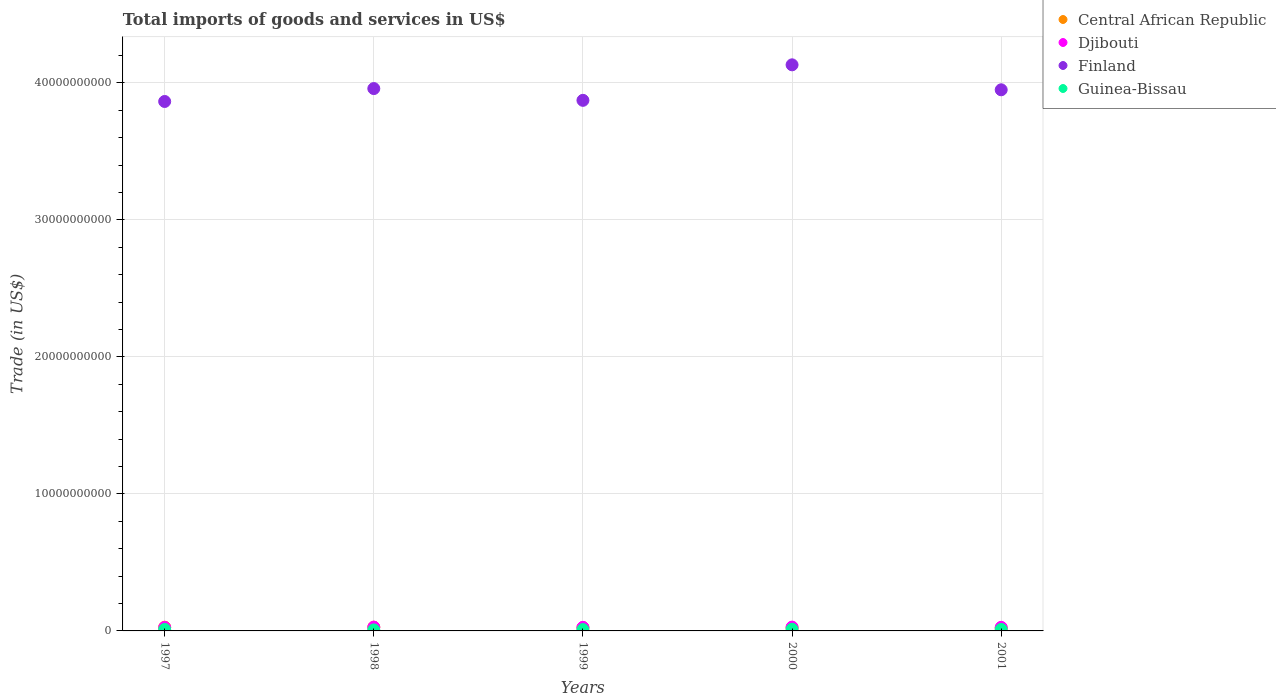What is the total imports of goods and services in Finland in 2001?
Provide a short and direct response. 3.95e+1. Across all years, what is the maximum total imports of goods and services in Central African Republic?
Keep it short and to the point. 2.75e+08. Across all years, what is the minimum total imports of goods and services in Guinea-Bissau?
Make the answer very short. 7.40e+07. What is the total total imports of goods and services in Guinea-Bissau in the graph?
Ensure brevity in your answer.  5.05e+08. What is the difference between the total imports of goods and services in Central African Republic in 1999 and that in 2000?
Ensure brevity in your answer.  8.51e+06. What is the difference between the total imports of goods and services in Central African Republic in 2000 and the total imports of goods and services in Finland in 2001?
Your answer should be very brief. -3.93e+1. What is the average total imports of goods and services in Central African Republic per year?
Offer a very short reply. 2.45e+08. In the year 2000, what is the difference between the total imports of goods and services in Central African Republic and total imports of goods and services in Djibouti?
Keep it short and to the point. -4.65e+07. In how many years, is the total imports of goods and services in Djibouti greater than 22000000000 US$?
Your response must be concise. 0. What is the ratio of the total imports of goods and services in Guinea-Bissau in 1999 to that in 2001?
Your answer should be compact. 0.91. Is the total imports of goods and services in Djibouti in 1998 less than that in 1999?
Your answer should be compact. No. What is the difference between the highest and the second highest total imports of goods and services in Central African Republic?
Provide a short and direct response. 3.32e+06. What is the difference between the highest and the lowest total imports of goods and services in Guinea-Bissau?
Give a very brief answer. 4.86e+07. In how many years, is the total imports of goods and services in Finland greater than the average total imports of goods and services in Finland taken over all years?
Provide a succinct answer. 2. Is the sum of the total imports of goods and services in Finland in 1997 and 2001 greater than the maximum total imports of goods and services in Guinea-Bissau across all years?
Keep it short and to the point. Yes. Is it the case that in every year, the sum of the total imports of goods and services in Djibouti and total imports of goods and services in Finland  is greater than the total imports of goods and services in Guinea-Bissau?
Provide a succinct answer. Yes. Does the total imports of goods and services in Djibouti monotonically increase over the years?
Offer a very short reply. No. Is the total imports of goods and services in Central African Republic strictly less than the total imports of goods and services in Djibouti over the years?
Make the answer very short. No. How many years are there in the graph?
Your answer should be very brief. 5. What is the difference between two consecutive major ticks on the Y-axis?
Provide a succinct answer. 1.00e+1. Does the graph contain any zero values?
Make the answer very short. No. Where does the legend appear in the graph?
Ensure brevity in your answer.  Top right. How many legend labels are there?
Provide a succinct answer. 4. How are the legend labels stacked?
Your answer should be compact. Vertical. What is the title of the graph?
Your response must be concise. Total imports of goods and services in US$. What is the label or title of the X-axis?
Your response must be concise. Years. What is the label or title of the Y-axis?
Provide a succinct answer. Trade (in US$). What is the Trade (in US$) in Central African Republic in 1997?
Provide a short and direct response. 2.71e+08. What is the Trade (in US$) of Djibouti in 1997?
Your answer should be very brief. 2.53e+08. What is the Trade (in US$) of Finland in 1997?
Ensure brevity in your answer.  3.86e+1. What is the Trade (in US$) in Guinea-Bissau in 1997?
Make the answer very short. 1.07e+08. What is the Trade (in US$) in Central African Republic in 1998?
Provide a short and direct response. 2.75e+08. What is the Trade (in US$) in Djibouti in 1998?
Keep it short and to the point. 2.75e+08. What is the Trade (in US$) of Finland in 1998?
Your answer should be very brief. 3.96e+1. What is the Trade (in US$) of Guinea-Bissau in 1998?
Ensure brevity in your answer.  7.40e+07. What is the Trade (in US$) of Central African Republic in 1999?
Provide a succinct answer. 2.40e+08. What is the Trade (in US$) in Djibouti in 1999?
Your response must be concise. 2.59e+08. What is the Trade (in US$) of Finland in 1999?
Provide a short and direct response. 3.87e+1. What is the Trade (in US$) in Guinea-Bissau in 1999?
Give a very brief answer. 9.61e+07. What is the Trade (in US$) in Central African Republic in 2000?
Offer a terse response. 2.31e+08. What is the Trade (in US$) in Djibouti in 2000?
Provide a succinct answer. 2.78e+08. What is the Trade (in US$) of Finland in 2000?
Your answer should be compact. 4.13e+1. What is the Trade (in US$) in Guinea-Bissau in 2000?
Provide a short and direct response. 1.23e+08. What is the Trade (in US$) of Central African Republic in 2001?
Your answer should be very brief. 2.10e+08. What is the Trade (in US$) of Djibouti in 2001?
Ensure brevity in your answer.  2.62e+08. What is the Trade (in US$) of Finland in 2001?
Your response must be concise. 3.95e+1. What is the Trade (in US$) in Guinea-Bissau in 2001?
Provide a short and direct response. 1.05e+08. Across all years, what is the maximum Trade (in US$) of Central African Republic?
Provide a short and direct response. 2.75e+08. Across all years, what is the maximum Trade (in US$) of Djibouti?
Keep it short and to the point. 2.78e+08. Across all years, what is the maximum Trade (in US$) of Finland?
Give a very brief answer. 4.13e+1. Across all years, what is the maximum Trade (in US$) in Guinea-Bissau?
Your response must be concise. 1.23e+08. Across all years, what is the minimum Trade (in US$) in Central African Republic?
Ensure brevity in your answer.  2.10e+08. Across all years, what is the minimum Trade (in US$) in Djibouti?
Your response must be concise. 2.53e+08. Across all years, what is the minimum Trade (in US$) in Finland?
Keep it short and to the point. 3.86e+1. Across all years, what is the minimum Trade (in US$) in Guinea-Bissau?
Make the answer very short. 7.40e+07. What is the total Trade (in US$) of Central African Republic in the graph?
Offer a terse response. 1.23e+09. What is the total Trade (in US$) in Djibouti in the graph?
Your response must be concise. 1.33e+09. What is the total Trade (in US$) in Finland in the graph?
Make the answer very short. 1.98e+11. What is the total Trade (in US$) of Guinea-Bissau in the graph?
Make the answer very short. 5.05e+08. What is the difference between the Trade (in US$) in Central African Republic in 1997 and that in 1998?
Give a very brief answer. -3.32e+06. What is the difference between the Trade (in US$) of Djibouti in 1997 and that in 1998?
Ensure brevity in your answer.  -2.19e+07. What is the difference between the Trade (in US$) in Finland in 1997 and that in 1998?
Your response must be concise. -9.42e+08. What is the difference between the Trade (in US$) of Guinea-Bissau in 1997 and that in 1998?
Your response must be concise. 3.31e+07. What is the difference between the Trade (in US$) of Central African Republic in 1997 and that in 1999?
Give a very brief answer. 3.16e+07. What is the difference between the Trade (in US$) in Djibouti in 1997 and that in 1999?
Your answer should be very brief. -6.22e+06. What is the difference between the Trade (in US$) of Finland in 1997 and that in 1999?
Keep it short and to the point. -8.34e+07. What is the difference between the Trade (in US$) in Guinea-Bissau in 1997 and that in 1999?
Keep it short and to the point. 1.10e+07. What is the difference between the Trade (in US$) in Central African Republic in 1997 and that in 2000?
Ensure brevity in your answer.  4.01e+07. What is the difference between the Trade (in US$) in Djibouti in 1997 and that in 2000?
Provide a short and direct response. -2.47e+07. What is the difference between the Trade (in US$) in Finland in 1997 and that in 2000?
Provide a succinct answer. -2.67e+09. What is the difference between the Trade (in US$) of Guinea-Bissau in 1997 and that in 2000?
Make the answer very short. -1.55e+07. What is the difference between the Trade (in US$) in Central African Republic in 1997 and that in 2001?
Offer a very short reply. 6.10e+07. What is the difference between the Trade (in US$) of Djibouti in 1997 and that in 2001?
Offer a very short reply. -9.00e+06. What is the difference between the Trade (in US$) in Finland in 1997 and that in 2001?
Offer a terse response. -8.53e+08. What is the difference between the Trade (in US$) in Guinea-Bissau in 1997 and that in 2001?
Make the answer very short. 1.89e+06. What is the difference between the Trade (in US$) in Central African Republic in 1998 and that in 1999?
Offer a very short reply. 3.49e+07. What is the difference between the Trade (in US$) in Djibouti in 1998 and that in 1999?
Provide a short and direct response. 1.57e+07. What is the difference between the Trade (in US$) in Finland in 1998 and that in 1999?
Ensure brevity in your answer.  8.59e+08. What is the difference between the Trade (in US$) of Guinea-Bissau in 1998 and that in 1999?
Offer a very short reply. -2.21e+07. What is the difference between the Trade (in US$) in Central African Republic in 1998 and that in 2000?
Offer a terse response. 4.34e+07. What is the difference between the Trade (in US$) of Djibouti in 1998 and that in 2000?
Your response must be concise. -2.83e+06. What is the difference between the Trade (in US$) of Finland in 1998 and that in 2000?
Give a very brief answer. -1.73e+09. What is the difference between the Trade (in US$) of Guinea-Bissau in 1998 and that in 2000?
Provide a short and direct response. -4.86e+07. What is the difference between the Trade (in US$) of Central African Republic in 1998 and that in 2001?
Provide a short and direct response. 6.43e+07. What is the difference between the Trade (in US$) in Djibouti in 1998 and that in 2001?
Provide a succinct answer. 1.29e+07. What is the difference between the Trade (in US$) of Finland in 1998 and that in 2001?
Provide a succinct answer. 8.95e+07. What is the difference between the Trade (in US$) in Guinea-Bissau in 1998 and that in 2001?
Provide a succinct answer. -3.12e+07. What is the difference between the Trade (in US$) of Central African Republic in 1999 and that in 2000?
Offer a very short reply. 8.51e+06. What is the difference between the Trade (in US$) of Djibouti in 1999 and that in 2000?
Give a very brief answer. -1.85e+07. What is the difference between the Trade (in US$) in Finland in 1999 and that in 2000?
Offer a very short reply. -2.59e+09. What is the difference between the Trade (in US$) in Guinea-Bissau in 1999 and that in 2000?
Provide a succinct answer. -2.65e+07. What is the difference between the Trade (in US$) of Central African Republic in 1999 and that in 2001?
Give a very brief answer. 2.94e+07. What is the difference between the Trade (in US$) of Djibouti in 1999 and that in 2001?
Ensure brevity in your answer.  -2.78e+06. What is the difference between the Trade (in US$) of Finland in 1999 and that in 2001?
Give a very brief answer. -7.69e+08. What is the difference between the Trade (in US$) in Guinea-Bissau in 1999 and that in 2001?
Your response must be concise. -9.12e+06. What is the difference between the Trade (in US$) in Central African Republic in 2000 and that in 2001?
Offer a terse response. 2.09e+07. What is the difference between the Trade (in US$) in Djibouti in 2000 and that in 2001?
Ensure brevity in your answer.  1.57e+07. What is the difference between the Trade (in US$) of Finland in 2000 and that in 2001?
Keep it short and to the point. 1.82e+09. What is the difference between the Trade (in US$) of Guinea-Bissau in 2000 and that in 2001?
Provide a short and direct response. 1.74e+07. What is the difference between the Trade (in US$) in Central African Republic in 1997 and the Trade (in US$) in Djibouti in 1998?
Your response must be concise. -3.56e+06. What is the difference between the Trade (in US$) in Central African Republic in 1997 and the Trade (in US$) in Finland in 1998?
Offer a very short reply. -3.93e+1. What is the difference between the Trade (in US$) of Central African Republic in 1997 and the Trade (in US$) of Guinea-Bissau in 1998?
Your answer should be compact. 1.97e+08. What is the difference between the Trade (in US$) of Djibouti in 1997 and the Trade (in US$) of Finland in 1998?
Provide a short and direct response. -3.93e+1. What is the difference between the Trade (in US$) in Djibouti in 1997 and the Trade (in US$) in Guinea-Bissau in 1998?
Offer a terse response. 1.79e+08. What is the difference between the Trade (in US$) in Finland in 1997 and the Trade (in US$) in Guinea-Bissau in 1998?
Your answer should be compact. 3.86e+1. What is the difference between the Trade (in US$) of Central African Republic in 1997 and the Trade (in US$) of Djibouti in 1999?
Offer a terse response. 1.21e+07. What is the difference between the Trade (in US$) of Central African Republic in 1997 and the Trade (in US$) of Finland in 1999?
Provide a succinct answer. -3.84e+1. What is the difference between the Trade (in US$) of Central African Republic in 1997 and the Trade (in US$) of Guinea-Bissau in 1999?
Provide a short and direct response. 1.75e+08. What is the difference between the Trade (in US$) of Djibouti in 1997 and the Trade (in US$) of Finland in 1999?
Provide a short and direct response. -3.85e+1. What is the difference between the Trade (in US$) of Djibouti in 1997 and the Trade (in US$) of Guinea-Bissau in 1999?
Your answer should be compact. 1.57e+08. What is the difference between the Trade (in US$) of Finland in 1997 and the Trade (in US$) of Guinea-Bissau in 1999?
Provide a succinct answer. 3.85e+1. What is the difference between the Trade (in US$) in Central African Republic in 1997 and the Trade (in US$) in Djibouti in 2000?
Provide a succinct answer. -6.39e+06. What is the difference between the Trade (in US$) of Central African Republic in 1997 and the Trade (in US$) of Finland in 2000?
Your answer should be compact. -4.10e+1. What is the difference between the Trade (in US$) in Central African Republic in 1997 and the Trade (in US$) in Guinea-Bissau in 2000?
Ensure brevity in your answer.  1.49e+08. What is the difference between the Trade (in US$) of Djibouti in 1997 and the Trade (in US$) of Finland in 2000?
Provide a succinct answer. -4.11e+1. What is the difference between the Trade (in US$) of Djibouti in 1997 and the Trade (in US$) of Guinea-Bissau in 2000?
Your answer should be very brief. 1.30e+08. What is the difference between the Trade (in US$) of Finland in 1997 and the Trade (in US$) of Guinea-Bissau in 2000?
Provide a short and direct response. 3.85e+1. What is the difference between the Trade (in US$) in Central African Republic in 1997 and the Trade (in US$) in Djibouti in 2001?
Offer a terse response. 9.32e+06. What is the difference between the Trade (in US$) in Central African Republic in 1997 and the Trade (in US$) in Finland in 2001?
Your response must be concise. -3.92e+1. What is the difference between the Trade (in US$) in Central African Republic in 1997 and the Trade (in US$) in Guinea-Bissau in 2001?
Provide a succinct answer. 1.66e+08. What is the difference between the Trade (in US$) of Djibouti in 1997 and the Trade (in US$) of Finland in 2001?
Provide a short and direct response. -3.92e+1. What is the difference between the Trade (in US$) in Djibouti in 1997 and the Trade (in US$) in Guinea-Bissau in 2001?
Your response must be concise. 1.48e+08. What is the difference between the Trade (in US$) in Finland in 1997 and the Trade (in US$) in Guinea-Bissau in 2001?
Provide a short and direct response. 3.85e+1. What is the difference between the Trade (in US$) of Central African Republic in 1998 and the Trade (in US$) of Djibouti in 1999?
Give a very brief answer. 1.54e+07. What is the difference between the Trade (in US$) of Central African Republic in 1998 and the Trade (in US$) of Finland in 1999?
Keep it short and to the point. -3.84e+1. What is the difference between the Trade (in US$) of Central African Republic in 1998 and the Trade (in US$) of Guinea-Bissau in 1999?
Your response must be concise. 1.79e+08. What is the difference between the Trade (in US$) in Djibouti in 1998 and the Trade (in US$) in Finland in 1999?
Keep it short and to the point. -3.84e+1. What is the difference between the Trade (in US$) of Djibouti in 1998 and the Trade (in US$) of Guinea-Bissau in 1999?
Keep it short and to the point. 1.79e+08. What is the difference between the Trade (in US$) of Finland in 1998 and the Trade (in US$) of Guinea-Bissau in 1999?
Provide a succinct answer. 3.95e+1. What is the difference between the Trade (in US$) in Central African Republic in 1998 and the Trade (in US$) in Djibouti in 2000?
Keep it short and to the point. -3.07e+06. What is the difference between the Trade (in US$) of Central African Republic in 1998 and the Trade (in US$) of Finland in 2000?
Provide a succinct answer. -4.10e+1. What is the difference between the Trade (in US$) of Central African Republic in 1998 and the Trade (in US$) of Guinea-Bissau in 2000?
Offer a very short reply. 1.52e+08. What is the difference between the Trade (in US$) of Djibouti in 1998 and the Trade (in US$) of Finland in 2000?
Your response must be concise. -4.10e+1. What is the difference between the Trade (in US$) in Djibouti in 1998 and the Trade (in US$) in Guinea-Bissau in 2000?
Provide a succinct answer. 1.52e+08. What is the difference between the Trade (in US$) in Finland in 1998 and the Trade (in US$) in Guinea-Bissau in 2000?
Your answer should be compact. 3.95e+1. What is the difference between the Trade (in US$) in Central African Republic in 1998 and the Trade (in US$) in Djibouti in 2001?
Your answer should be very brief. 1.26e+07. What is the difference between the Trade (in US$) in Central African Republic in 1998 and the Trade (in US$) in Finland in 2001?
Give a very brief answer. -3.92e+1. What is the difference between the Trade (in US$) of Central African Republic in 1998 and the Trade (in US$) of Guinea-Bissau in 2001?
Provide a succinct answer. 1.69e+08. What is the difference between the Trade (in US$) in Djibouti in 1998 and the Trade (in US$) in Finland in 2001?
Offer a terse response. -3.92e+1. What is the difference between the Trade (in US$) of Djibouti in 1998 and the Trade (in US$) of Guinea-Bissau in 2001?
Make the answer very short. 1.70e+08. What is the difference between the Trade (in US$) of Finland in 1998 and the Trade (in US$) of Guinea-Bissau in 2001?
Ensure brevity in your answer.  3.95e+1. What is the difference between the Trade (in US$) in Central African Republic in 1999 and the Trade (in US$) in Djibouti in 2000?
Offer a very short reply. -3.80e+07. What is the difference between the Trade (in US$) in Central African Republic in 1999 and the Trade (in US$) in Finland in 2000?
Keep it short and to the point. -4.11e+1. What is the difference between the Trade (in US$) of Central African Republic in 1999 and the Trade (in US$) of Guinea-Bissau in 2000?
Keep it short and to the point. 1.17e+08. What is the difference between the Trade (in US$) in Djibouti in 1999 and the Trade (in US$) in Finland in 2000?
Provide a short and direct response. -4.11e+1. What is the difference between the Trade (in US$) of Djibouti in 1999 and the Trade (in US$) of Guinea-Bissau in 2000?
Provide a succinct answer. 1.37e+08. What is the difference between the Trade (in US$) in Finland in 1999 and the Trade (in US$) in Guinea-Bissau in 2000?
Provide a succinct answer. 3.86e+1. What is the difference between the Trade (in US$) of Central African Republic in 1999 and the Trade (in US$) of Djibouti in 2001?
Ensure brevity in your answer.  -2.22e+07. What is the difference between the Trade (in US$) in Central African Republic in 1999 and the Trade (in US$) in Finland in 2001?
Your answer should be very brief. -3.93e+1. What is the difference between the Trade (in US$) of Central African Republic in 1999 and the Trade (in US$) of Guinea-Bissau in 2001?
Give a very brief answer. 1.35e+08. What is the difference between the Trade (in US$) in Djibouti in 1999 and the Trade (in US$) in Finland in 2001?
Make the answer very short. -3.92e+1. What is the difference between the Trade (in US$) in Djibouti in 1999 and the Trade (in US$) in Guinea-Bissau in 2001?
Offer a very short reply. 1.54e+08. What is the difference between the Trade (in US$) of Finland in 1999 and the Trade (in US$) of Guinea-Bissau in 2001?
Your answer should be very brief. 3.86e+1. What is the difference between the Trade (in US$) of Central African Republic in 2000 and the Trade (in US$) of Djibouti in 2001?
Your answer should be very brief. -3.08e+07. What is the difference between the Trade (in US$) in Central African Republic in 2000 and the Trade (in US$) in Finland in 2001?
Offer a terse response. -3.93e+1. What is the difference between the Trade (in US$) of Central African Republic in 2000 and the Trade (in US$) of Guinea-Bissau in 2001?
Offer a very short reply. 1.26e+08. What is the difference between the Trade (in US$) of Djibouti in 2000 and the Trade (in US$) of Finland in 2001?
Offer a terse response. -3.92e+1. What is the difference between the Trade (in US$) in Djibouti in 2000 and the Trade (in US$) in Guinea-Bissau in 2001?
Your answer should be compact. 1.73e+08. What is the difference between the Trade (in US$) of Finland in 2000 and the Trade (in US$) of Guinea-Bissau in 2001?
Keep it short and to the point. 4.12e+1. What is the average Trade (in US$) in Central African Republic per year?
Provide a succinct answer. 2.45e+08. What is the average Trade (in US$) in Djibouti per year?
Your answer should be compact. 2.65e+08. What is the average Trade (in US$) of Finland per year?
Keep it short and to the point. 3.95e+1. What is the average Trade (in US$) of Guinea-Bissau per year?
Keep it short and to the point. 1.01e+08. In the year 1997, what is the difference between the Trade (in US$) of Central African Republic and Trade (in US$) of Djibouti?
Give a very brief answer. 1.83e+07. In the year 1997, what is the difference between the Trade (in US$) in Central African Republic and Trade (in US$) in Finland?
Provide a succinct answer. -3.84e+1. In the year 1997, what is the difference between the Trade (in US$) in Central African Republic and Trade (in US$) in Guinea-Bissau?
Your answer should be very brief. 1.64e+08. In the year 1997, what is the difference between the Trade (in US$) of Djibouti and Trade (in US$) of Finland?
Make the answer very short. -3.84e+1. In the year 1997, what is the difference between the Trade (in US$) of Djibouti and Trade (in US$) of Guinea-Bissau?
Provide a succinct answer. 1.46e+08. In the year 1997, what is the difference between the Trade (in US$) in Finland and Trade (in US$) in Guinea-Bissau?
Your answer should be very brief. 3.85e+1. In the year 1998, what is the difference between the Trade (in US$) of Central African Republic and Trade (in US$) of Djibouti?
Offer a terse response. -2.39e+05. In the year 1998, what is the difference between the Trade (in US$) in Central African Republic and Trade (in US$) in Finland?
Offer a terse response. -3.93e+1. In the year 1998, what is the difference between the Trade (in US$) in Central African Republic and Trade (in US$) in Guinea-Bissau?
Your response must be concise. 2.01e+08. In the year 1998, what is the difference between the Trade (in US$) in Djibouti and Trade (in US$) in Finland?
Make the answer very short. -3.93e+1. In the year 1998, what is the difference between the Trade (in US$) of Djibouti and Trade (in US$) of Guinea-Bissau?
Offer a terse response. 2.01e+08. In the year 1998, what is the difference between the Trade (in US$) in Finland and Trade (in US$) in Guinea-Bissau?
Ensure brevity in your answer.  3.95e+1. In the year 1999, what is the difference between the Trade (in US$) in Central African Republic and Trade (in US$) in Djibouti?
Your response must be concise. -1.95e+07. In the year 1999, what is the difference between the Trade (in US$) in Central African Republic and Trade (in US$) in Finland?
Make the answer very short. -3.85e+1. In the year 1999, what is the difference between the Trade (in US$) of Central African Republic and Trade (in US$) of Guinea-Bissau?
Give a very brief answer. 1.44e+08. In the year 1999, what is the difference between the Trade (in US$) in Djibouti and Trade (in US$) in Finland?
Offer a terse response. -3.85e+1. In the year 1999, what is the difference between the Trade (in US$) in Djibouti and Trade (in US$) in Guinea-Bissau?
Make the answer very short. 1.63e+08. In the year 1999, what is the difference between the Trade (in US$) in Finland and Trade (in US$) in Guinea-Bissau?
Provide a succinct answer. 3.86e+1. In the year 2000, what is the difference between the Trade (in US$) of Central African Republic and Trade (in US$) of Djibouti?
Offer a terse response. -4.65e+07. In the year 2000, what is the difference between the Trade (in US$) in Central African Republic and Trade (in US$) in Finland?
Provide a succinct answer. -4.11e+1. In the year 2000, what is the difference between the Trade (in US$) of Central African Republic and Trade (in US$) of Guinea-Bissau?
Offer a terse response. 1.09e+08. In the year 2000, what is the difference between the Trade (in US$) of Djibouti and Trade (in US$) of Finland?
Your answer should be very brief. -4.10e+1. In the year 2000, what is the difference between the Trade (in US$) of Djibouti and Trade (in US$) of Guinea-Bissau?
Provide a short and direct response. 1.55e+08. In the year 2000, what is the difference between the Trade (in US$) in Finland and Trade (in US$) in Guinea-Bissau?
Provide a succinct answer. 4.12e+1. In the year 2001, what is the difference between the Trade (in US$) in Central African Republic and Trade (in US$) in Djibouti?
Keep it short and to the point. -5.17e+07. In the year 2001, what is the difference between the Trade (in US$) of Central African Republic and Trade (in US$) of Finland?
Offer a terse response. -3.93e+1. In the year 2001, what is the difference between the Trade (in US$) of Central African Republic and Trade (in US$) of Guinea-Bissau?
Your answer should be very brief. 1.05e+08. In the year 2001, what is the difference between the Trade (in US$) of Djibouti and Trade (in US$) of Finland?
Offer a terse response. -3.92e+1. In the year 2001, what is the difference between the Trade (in US$) in Djibouti and Trade (in US$) in Guinea-Bissau?
Your response must be concise. 1.57e+08. In the year 2001, what is the difference between the Trade (in US$) of Finland and Trade (in US$) of Guinea-Bissau?
Keep it short and to the point. 3.94e+1. What is the ratio of the Trade (in US$) of Central African Republic in 1997 to that in 1998?
Offer a terse response. 0.99. What is the ratio of the Trade (in US$) of Djibouti in 1997 to that in 1998?
Provide a succinct answer. 0.92. What is the ratio of the Trade (in US$) of Finland in 1997 to that in 1998?
Keep it short and to the point. 0.98. What is the ratio of the Trade (in US$) of Guinea-Bissau in 1997 to that in 1998?
Keep it short and to the point. 1.45. What is the ratio of the Trade (in US$) of Central African Republic in 1997 to that in 1999?
Give a very brief answer. 1.13. What is the ratio of the Trade (in US$) of Djibouti in 1997 to that in 1999?
Your answer should be very brief. 0.98. What is the ratio of the Trade (in US$) in Finland in 1997 to that in 1999?
Your answer should be compact. 1. What is the ratio of the Trade (in US$) in Guinea-Bissau in 1997 to that in 1999?
Provide a short and direct response. 1.11. What is the ratio of the Trade (in US$) of Central African Republic in 1997 to that in 2000?
Offer a terse response. 1.17. What is the ratio of the Trade (in US$) of Djibouti in 1997 to that in 2000?
Your answer should be very brief. 0.91. What is the ratio of the Trade (in US$) of Finland in 1997 to that in 2000?
Provide a short and direct response. 0.94. What is the ratio of the Trade (in US$) of Guinea-Bissau in 1997 to that in 2000?
Offer a very short reply. 0.87. What is the ratio of the Trade (in US$) in Central African Republic in 1997 to that in 2001?
Your response must be concise. 1.29. What is the ratio of the Trade (in US$) of Djibouti in 1997 to that in 2001?
Make the answer very short. 0.97. What is the ratio of the Trade (in US$) of Finland in 1997 to that in 2001?
Your response must be concise. 0.98. What is the ratio of the Trade (in US$) in Guinea-Bissau in 1997 to that in 2001?
Give a very brief answer. 1.02. What is the ratio of the Trade (in US$) of Central African Republic in 1998 to that in 1999?
Your response must be concise. 1.15. What is the ratio of the Trade (in US$) in Djibouti in 1998 to that in 1999?
Offer a very short reply. 1.06. What is the ratio of the Trade (in US$) in Finland in 1998 to that in 1999?
Provide a short and direct response. 1.02. What is the ratio of the Trade (in US$) in Guinea-Bissau in 1998 to that in 1999?
Provide a short and direct response. 0.77. What is the ratio of the Trade (in US$) in Central African Republic in 1998 to that in 2000?
Ensure brevity in your answer.  1.19. What is the ratio of the Trade (in US$) in Finland in 1998 to that in 2000?
Ensure brevity in your answer.  0.96. What is the ratio of the Trade (in US$) of Guinea-Bissau in 1998 to that in 2000?
Ensure brevity in your answer.  0.6. What is the ratio of the Trade (in US$) in Central African Republic in 1998 to that in 2001?
Your response must be concise. 1.31. What is the ratio of the Trade (in US$) of Djibouti in 1998 to that in 2001?
Your answer should be very brief. 1.05. What is the ratio of the Trade (in US$) of Finland in 1998 to that in 2001?
Provide a succinct answer. 1. What is the ratio of the Trade (in US$) in Guinea-Bissau in 1998 to that in 2001?
Ensure brevity in your answer.  0.7. What is the ratio of the Trade (in US$) of Central African Republic in 1999 to that in 2000?
Your answer should be compact. 1.04. What is the ratio of the Trade (in US$) in Djibouti in 1999 to that in 2000?
Keep it short and to the point. 0.93. What is the ratio of the Trade (in US$) of Finland in 1999 to that in 2000?
Offer a very short reply. 0.94. What is the ratio of the Trade (in US$) in Guinea-Bissau in 1999 to that in 2000?
Make the answer very short. 0.78. What is the ratio of the Trade (in US$) of Central African Republic in 1999 to that in 2001?
Your answer should be very brief. 1.14. What is the ratio of the Trade (in US$) in Djibouti in 1999 to that in 2001?
Offer a very short reply. 0.99. What is the ratio of the Trade (in US$) of Finland in 1999 to that in 2001?
Offer a terse response. 0.98. What is the ratio of the Trade (in US$) of Guinea-Bissau in 1999 to that in 2001?
Provide a succinct answer. 0.91. What is the ratio of the Trade (in US$) of Central African Republic in 2000 to that in 2001?
Make the answer very short. 1.1. What is the ratio of the Trade (in US$) of Djibouti in 2000 to that in 2001?
Your answer should be compact. 1.06. What is the ratio of the Trade (in US$) of Finland in 2000 to that in 2001?
Keep it short and to the point. 1.05. What is the ratio of the Trade (in US$) in Guinea-Bissau in 2000 to that in 2001?
Your response must be concise. 1.17. What is the difference between the highest and the second highest Trade (in US$) in Central African Republic?
Ensure brevity in your answer.  3.32e+06. What is the difference between the highest and the second highest Trade (in US$) in Djibouti?
Keep it short and to the point. 2.83e+06. What is the difference between the highest and the second highest Trade (in US$) in Finland?
Your response must be concise. 1.73e+09. What is the difference between the highest and the second highest Trade (in US$) in Guinea-Bissau?
Offer a very short reply. 1.55e+07. What is the difference between the highest and the lowest Trade (in US$) in Central African Republic?
Your answer should be compact. 6.43e+07. What is the difference between the highest and the lowest Trade (in US$) of Djibouti?
Ensure brevity in your answer.  2.47e+07. What is the difference between the highest and the lowest Trade (in US$) in Finland?
Offer a very short reply. 2.67e+09. What is the difference between the highest and the lowest Trade (in US$) of Guinea-Bissau?
Offer a very short reply. 4.86e+07. 